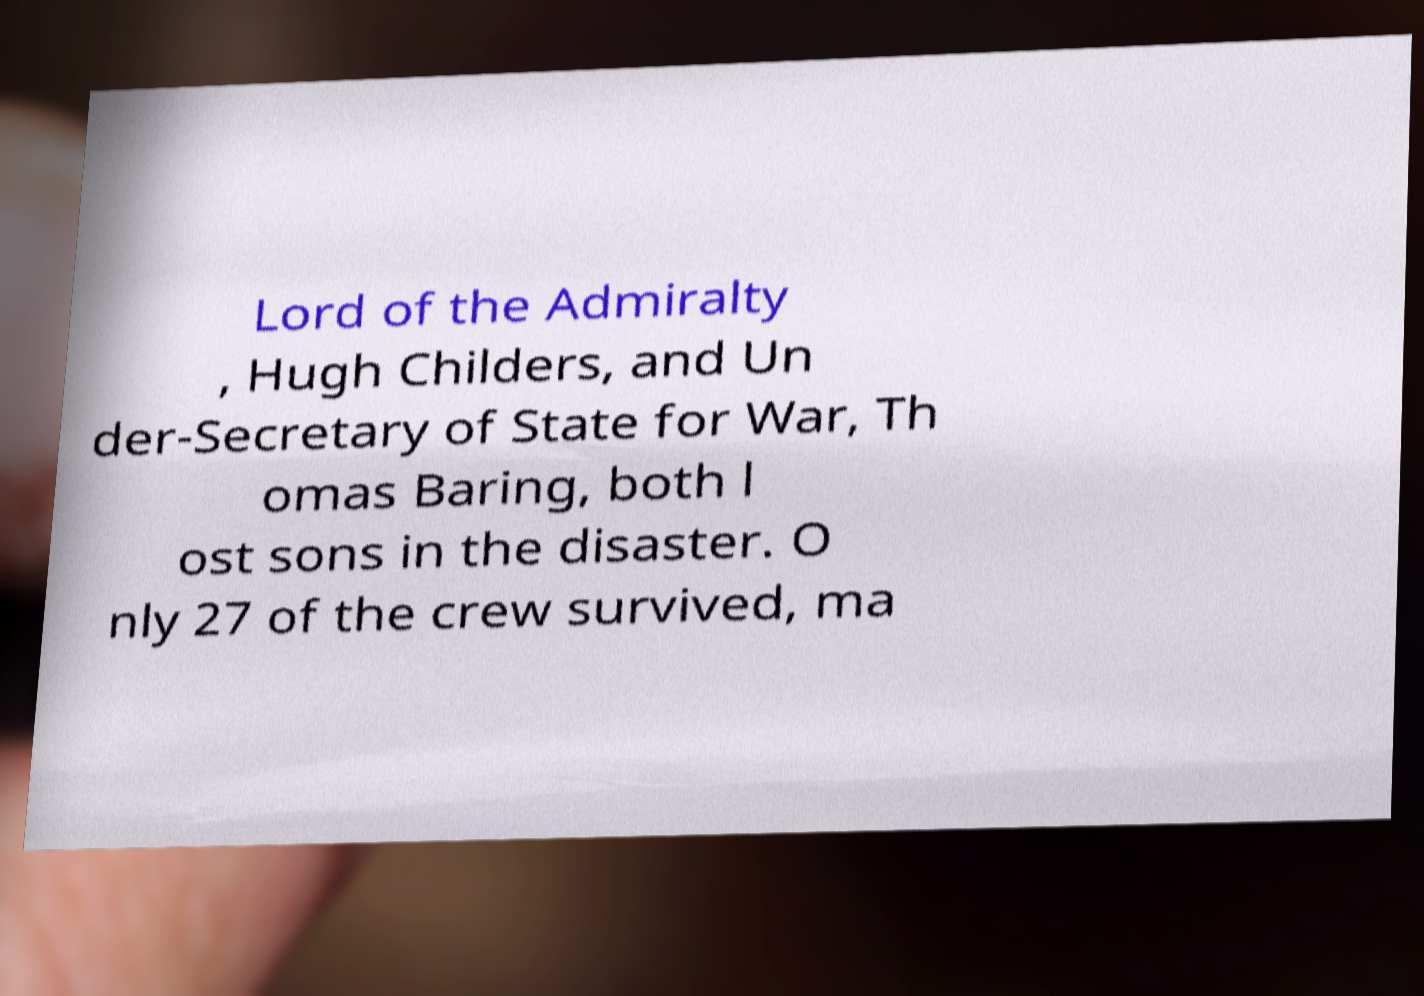For documentation purposes, I need the text within this image transcribed. Could you provide that? Lord of the Admiralty , Hugh Childers, and Un der-Secretary of State for War, Th omas Baring, both l ost sons in the disaster. O nly 27 of the crew survived, ma 